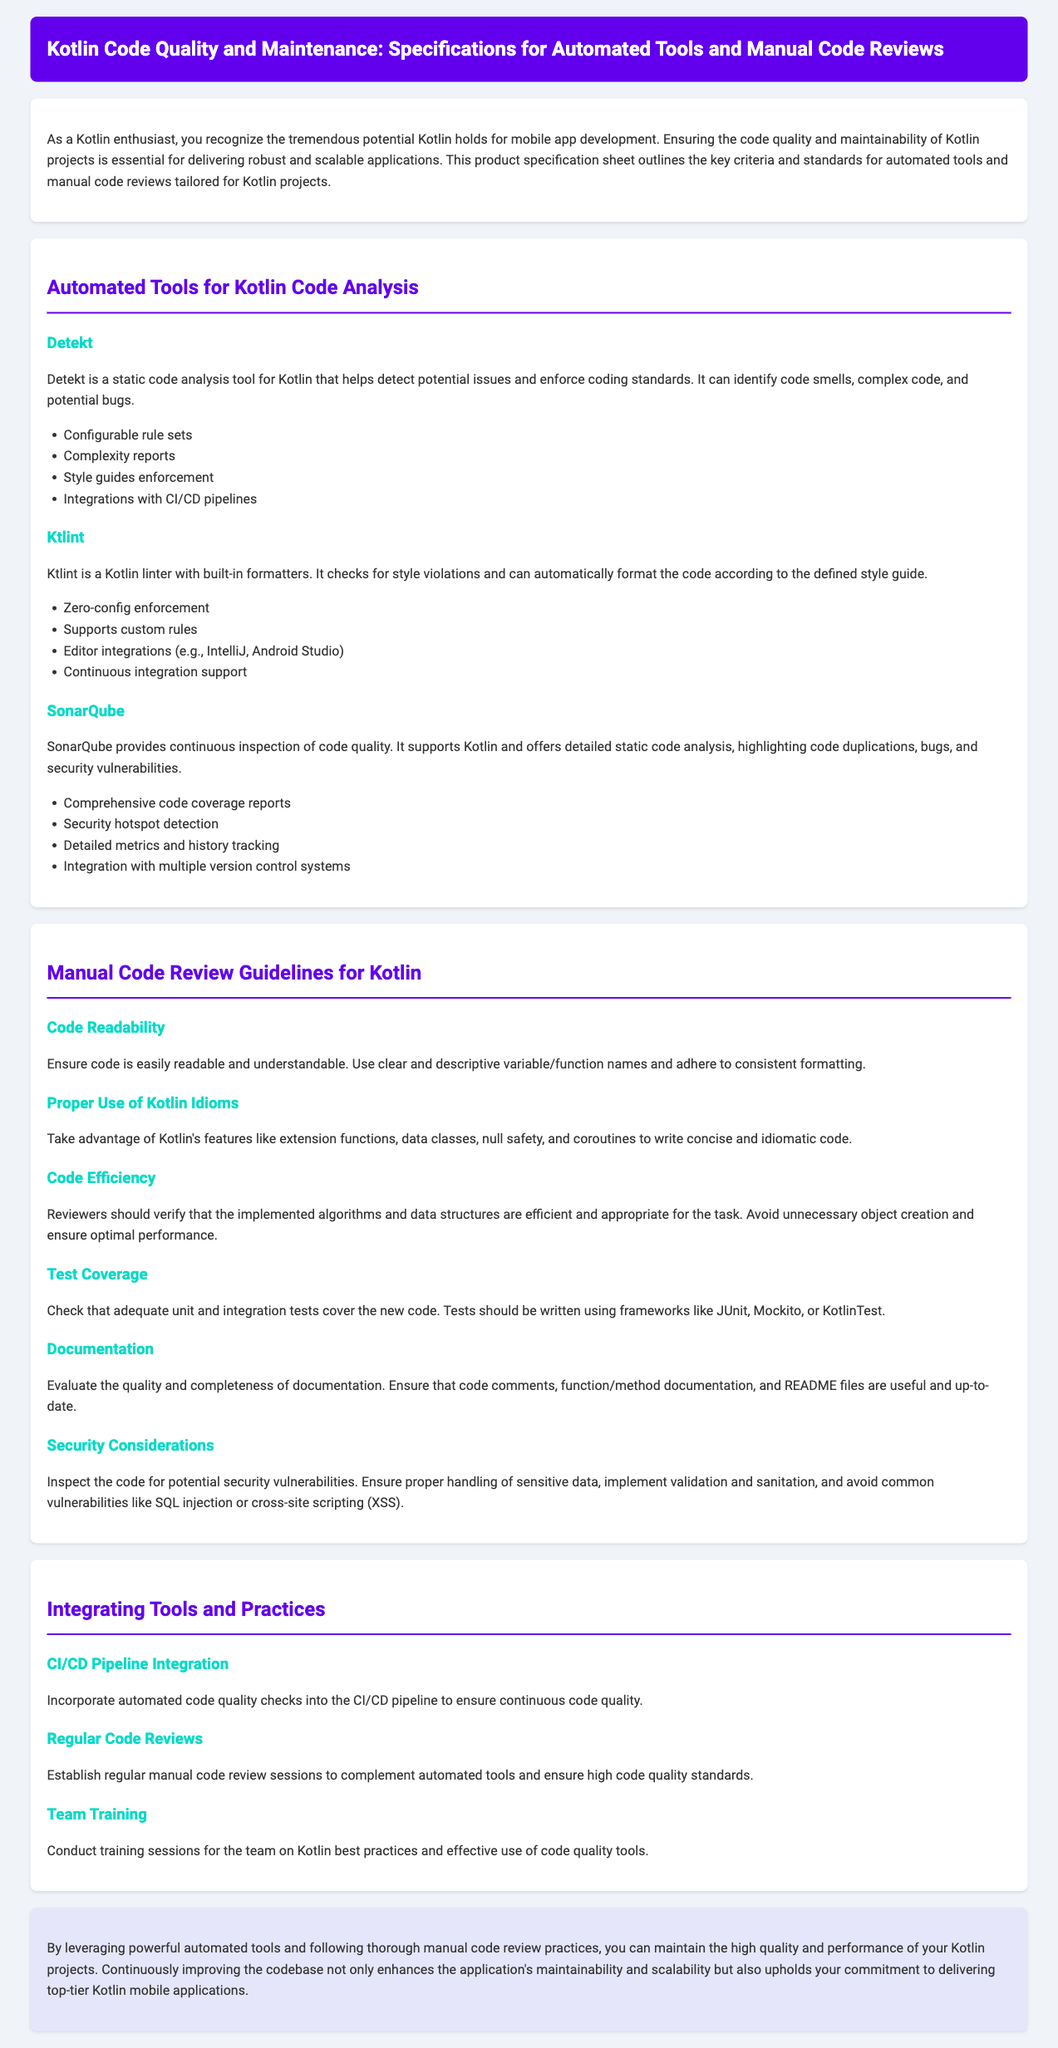What is the title of the document? The title of the document is stated in the header section of the document.
Answer: Kotlin Code Quality and Maintenance: Specifications for Automated Tools and Manual Code Reviews How many automated tools are listed for Kotlin code analysis? The document lists three automated tools for Kotlin code analysis in the corresponding section.
Answer: Three What is the main purpose of Detekt? The purpose of Detekt is mentioned in its description within the documentation.
Answer: Static code analysis What coding framework is mentioned for test coverage? The document specifies the frameworks to be used for test coverage in the guidelines section.
Answer: JUnit Which section discusses manual code review guidelines? The section is labeled clearly in the document to signify its content.
Answer: Manual Code Review Guidelines for Kotlin What is one of the criteria for manual code review? The document lists multiple criteria for manual code review, and an example can be taken from this section.
Answer: Code Readability Which tool provides continuous inspection of code quality? The specific tool that performs this function is mentioned in the automated tools section.
Answer: SonarQube What action item involves team training? The document lists an action item focused on educating team members on best practices.
Answer: Team Training What is one security consideration mentioned? The document includes specific security considerations under the manual review guidelines.
Answer: Handling sensitive data 